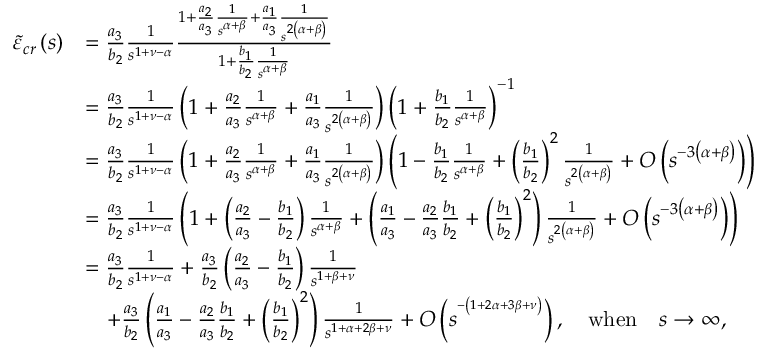Convert formula to latex. <formula><loc_0><loc_0><loc_500><loc_500>\begin{array} { r l } { \tilde { \varepsilon } _ { c r } \left ( s \right ) } & { = \frac { a _ { 3 } } { b _ { 2 } } \frac { 1 } { s ^ { 1 + \nu - \alpha } } \frac { 1 + \frac { a _ { 2 } } { a _ { 3 } } \frac { 1 } { s ^ { \alpha + \beta } } + \frac { a _ { 1 } } { a _ { 3 } } \frac { 1 } { s ^ { 2 \left ( \alpha + \beta \right ) } } } { 1 + \frac { b _ { 1 } } { b _ { 2 } } \frac { 1 } { s ^ { \alpha + \beta } } } } \\ & { = \frac { a _ { 3 } } { b _ { 2 } } \frac { 1 } { s ^ { 1 + \nu - \alpha } } \left ( 1 + \frac { a _ { 2 } } { a _ { 3 } } \frac { 1 } { s ^ { \alpha + \beta } } + \frac { a _ { 1 } } { a _ { 3 } } \frac { 1 } { s ^ { 2 \left ( \alpha + \beta \right ) } } \right ) \left ( 1 + \frac { b _ { 1 } } { b _ { 2 } } \frac { 1 } { s ^ { \alpha + \beta } } \right ) ^ { - 1 } } \\ & { = \frac { a _ { 3 } } { b _ { 2 } } \frac { 1 } { s ^ { 1 + \nu - \alpha } } \left ( 1 + \frac { a _ { 2 } } { a _ { 3 } } \frac { 1 } { s ^ { \alpha + \beta } } + \frac { a _ { 1 } } { a _ { 3 } } \frac { 1 } { s ^ { 2 \left ( \alpha + \beta \right ) } } \right ) \left ( 1 - \frac { b _ { 1 } } { b _ { 2 } } \frac { 1 } { s ^ { \alpha + \beta } } + \left ( \frac { b _ { 1 } } { b _ { 2 } } \right ) ^ { 2 } \frac { 1 } { s ^ { 2 \left ( \alpha + \beta \right ) } } + O \left ( s ^ { - 3 \left ( \alpha + \beta \right ) } \right ) \right ) } \\ & { = \frac { a _ { 3 } } { b _ { 2 } } \frac { 1 } { s ^ { 1 + \nu - \alpha } } \left ( 1 + \left ( \frac { a _ { 2 } } { a _ { 3 } } - \frac { b _ { 1 } } { b _ { 2 } } \right ) \frac { 1 } { s ^ { \alpha + \beta } } + \left ( \frac { a _ { 1 } } { a _ { 3 } } - \frac { a _ { 2 } } { a _ { 3 } } \frac { b _ { 1 } } { b _ { 2 } } + \left ( \frac { b _ { 1 } } { b _ { 2 } } \right ) ^ { 2 } \right ) \frac { 1 } { s ^ { 2 \left ( \alpha + \beta \right ) } } + O \left ( s ^ { - 3 \left ( \alpha + \beta \right ) } \right ) \right ) } \\ & { = \frac { a _ { 3 } } { b _ { 2 } } \frac { 1 } { s ^ { 1 + \nu - \alpha } } + \frac { a _ { 3 } } { b _ { 2 } } \left ( \frac { a _ { 2 } } { a _ { 3 } } - \frac { b _ { 1 } } { b _ { 2 } } \right ) \frac { 1 } { s ^ { 1 + \beta + \nu } } } \\ & { \quad + \frac { a _ { 3 } } { b _ { 2 } } \left ( \frac { a _ { 1 } } { a _ { 3 } } - \frac { a _ { 2 } } { a _ { 3 } } \frac { b _ { 1 } } { b _ { 2 } } + \left ( \frac { b _ { 1 } } { b _ { 2 } } \right ) ^ { 2 } \right ) \frac { 1 } { s ^ { 1 + \alpha + 2 \beta + \nu } } + O \left ( s ^ { ^ { - \left ( 1 + 2 \alpha + 3 \beta + \nu \right ) } } \right ) , \quad w h e n \quad s \rightarrow \infty , } \end{array}</formula> 